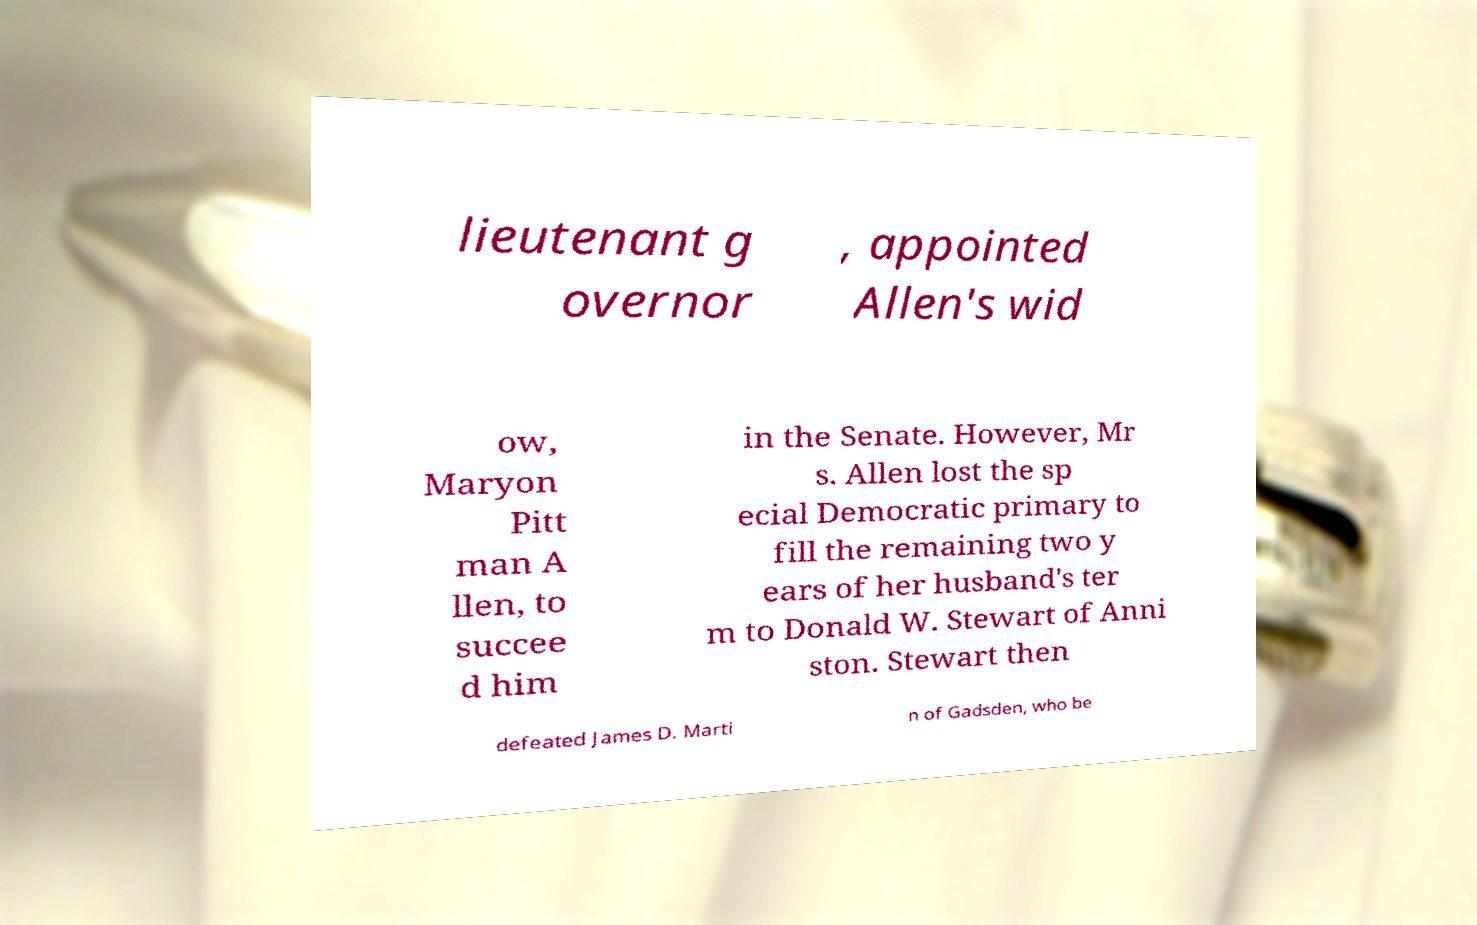For documentation purposes, I need the text within this image transcribed. Could you provide that? lieutenant g overnor , appointed Allen's wid ow, Maryon Pitt man A llen, to succee d him in the Senate. However, Mr s. Allen lost the sp ecial Democratic primary to fill the remaining two y ears of her husband's ter m to Donald W. Stewart of Anni ston. Stewart then defeated James D. Marti n of Gadsden, who be 